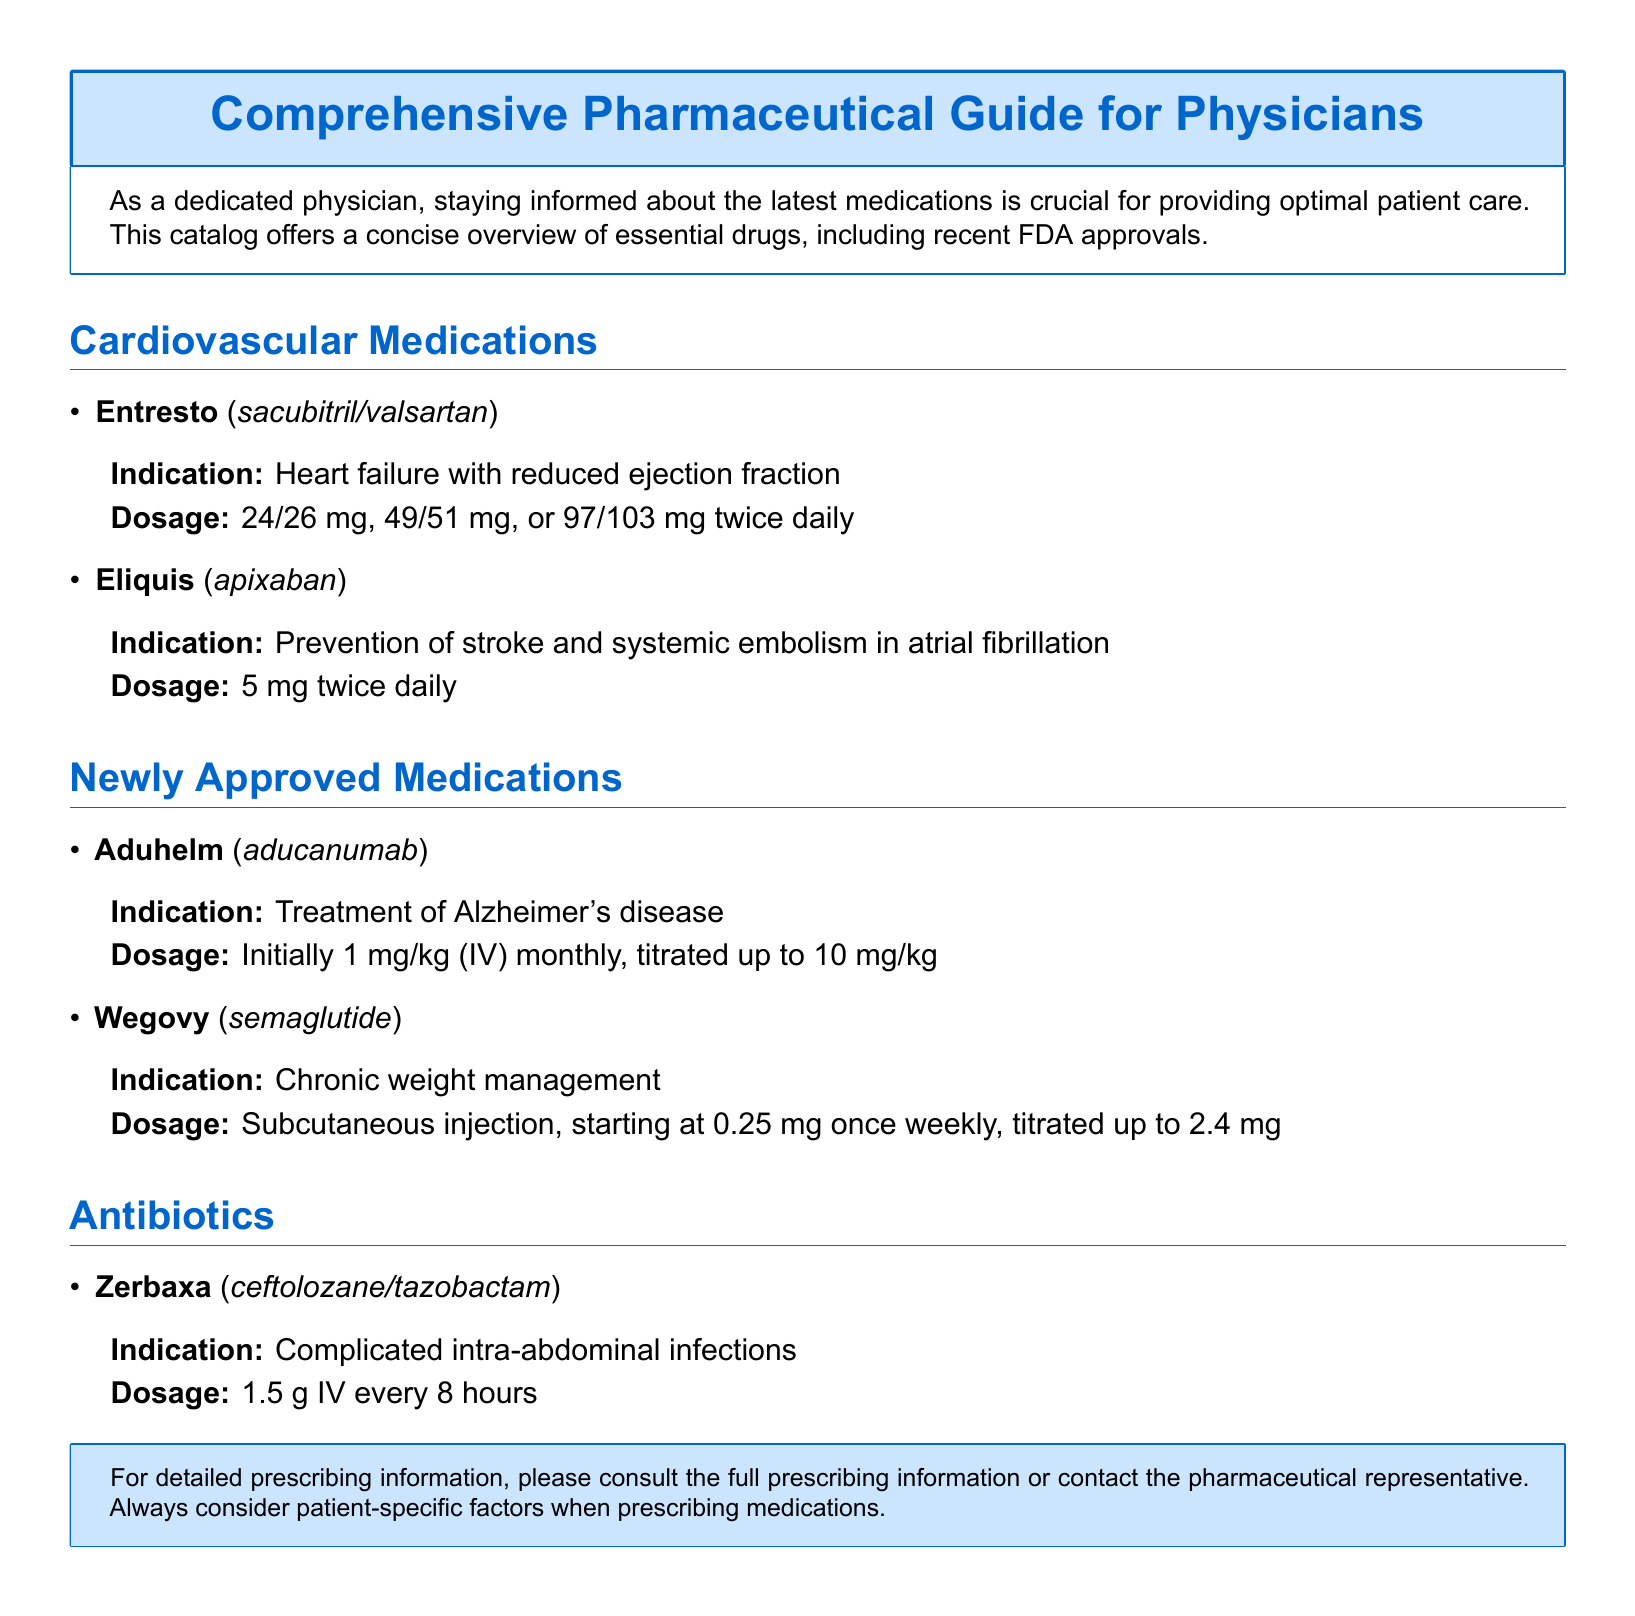What is the purpose of the catalog? The purpose of the catalog is to provide a concise overview of essential drugs, including recent FDA approvals, aiding physicians in keeping informed about the latest medications for optimal patient care.
Answer: optimal patient care What is the indication for Entresto? The indication for Entresto, which is listed under cardiovascular medications, is heart failure with reduced ejection fraction.
Answer: heart failure with reduced ejection fraction What is the dosage of Eliquis? The dosage of Eliquis prescribed for prevention of stroke and systemic embolism in atrial fibrillation is specified in the document.
Answer: 5 mg twice daily Which drug is newly approved for Alzheimer's disease? The document mentions Aduhelm as a newly approved drug for Alzheimer's disease treatment.
Answer: Aduhelm What are the two components of Zerbaxa? The document specifies that Zerbaxa is made up of ceftolozane and tazobactam, listed under antibiotics.
Answer: ceftolozane/tazobactam What is the starting dosage for Wegovy? The starting dosage of Wegovy for chronic weight management is mentioned in the catalog.
Answer: 0.25 mg once weekly How often is Entresto taken? The frequency of Entresto dosage is given in the medication description in the catalog.
Answer: twice daily What is the administration route for Aduhelm? The catalog provides the administration route for Aduhelm, which is needed for the reader's understanding of the drug.
Answer: IV 